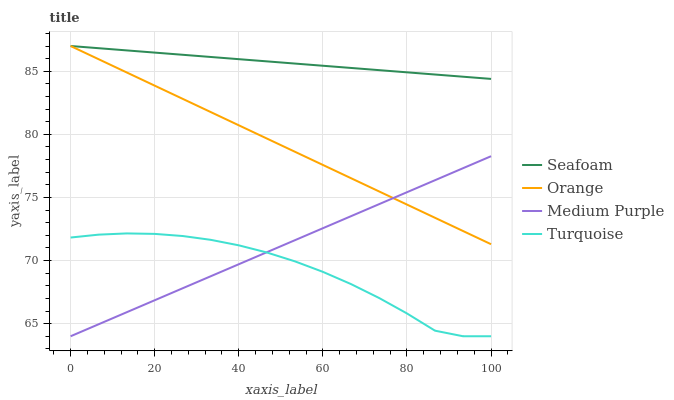Does Turquoise have the minimum area under the curve?
Answer yes or no. Yes. Does Seafoam have the maximum area under the curve?
Answer yes or no. Yes. Does Medium Purple have the minimum area under the curve?
Answer yes or no. No. Does Medium Purple have the maximum area under the curve?
Answer yes or no. No. Is Orange the smoothest?
Answer yes or no. Yes. Is Turquoise the roughest?
Answer yes or no. Yes. Is Medium Purple the smoothest?
Answer yes or no. No. Is Medium Purple the roughest?
Answer yes or no. No. Does Medium Purple have the lowest value?
Answer yes or no. Yes. Does Seafoam have the lowest value?
Answer yes or no. No. Does Seafoam have the highest value?
Answer yes or no. Yes. Does Medium Purple have the highest value?
Answer yes or no. No. Is Medium Purple less than Seafoam?
Answer yes or no. Yes. Is Seafoam greater than Medium Purple?
Answer yes or no. Yes. Does Medium Purple intersect Turquoise?
Answer yes or no. Yes. Is Medium Purple less than Turquoise?
Answer yes or no. No. Is Medium Purple greater than Turquoise?
Answer yes or no. No. Does Medium Purple intersect Seafoam?
Answer yes or no. No. 